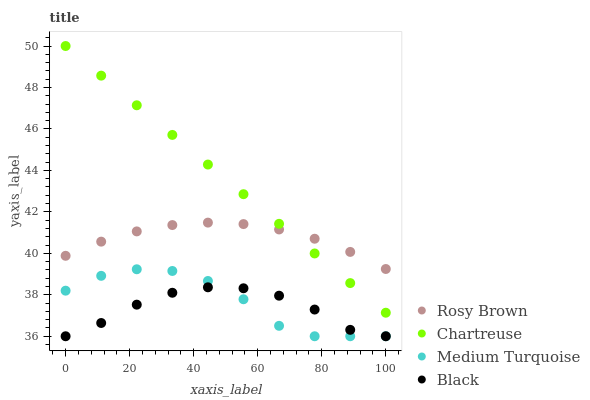Does Black have the minimum area under the curve?
Answer yes or no. Yes. Does Chartreuse have the maximum area under the curve?
Answer yes or no. Yes. Does Rosy Brown have the minimum area under the curve?
Answer yes or no. No. Does Rosy Brown have the maximum area under the curve?
Answer yes or no. No. Is Chartreuse the smoothest?
Answer yes or no. Yes. Is Medium Turquoise the roughest?
Answer yes or no. Yes. Is Rosy Brown the smoothest?
Answer yes or no. No. Is Rosy Brown the roughest?
Answer yes or no. No. Does Black have the lowest value?
Answer yes or no. Yes. Does Rosy Brown have the lowest value?
Answer yes or no. No. Does Chartreuse have the highest value?
Answer yes or no. Yes. Does Rosy Brown have the highest value?
Answer yes or no. No. Is Medium Turquoise less than Chartreuse?
Answer yes or no. Yes. Is Chartreuse greater than Medium Turquoise?
Answer yes or no. Yes. Does Rosy Brown intersect Chartreuse?
Answer yes or no. Yes. Is Rosy Brown less than Chartreuse?
Answer yes or no. No. Is Rosy Brown greater than Chartreuse?
Answer yes or no. No. Does Medium Turquoise intersect Chartreuse?
Answer yes or no. No. 